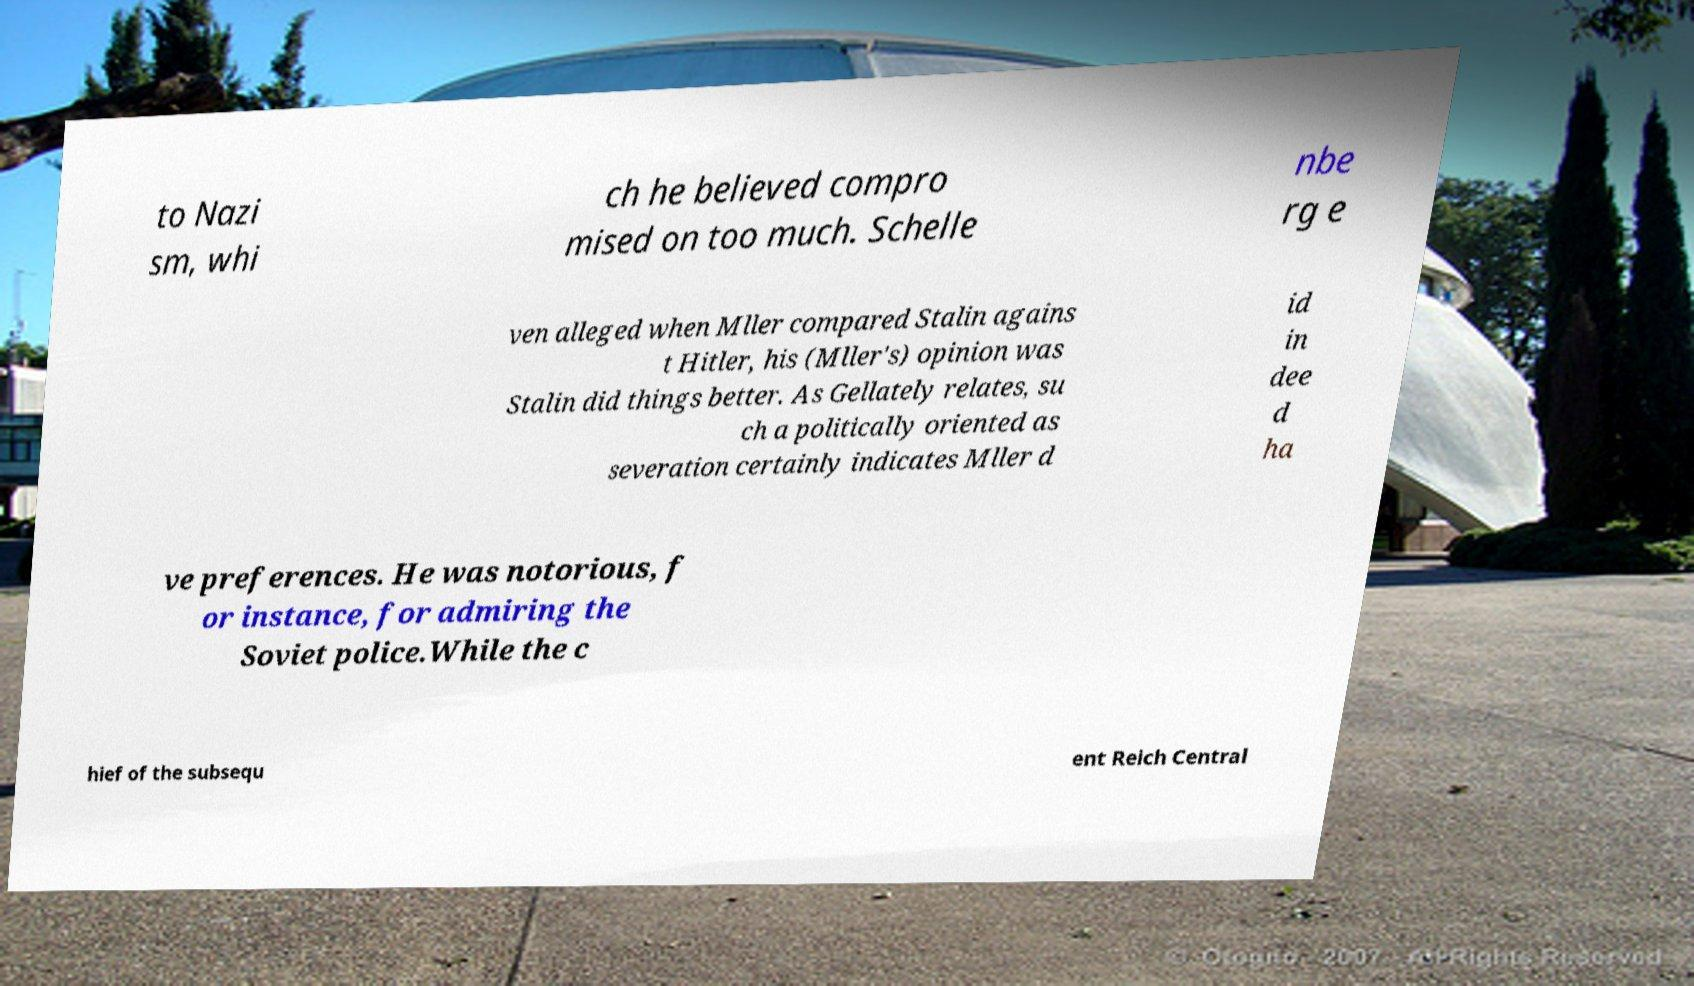Could you extract and type out the text from this image? to Nazi sm, whi ch he believed compro mised on too much. Schelle nbe rg e ven alleged when Mller compared Stalin agains t Hitler, his (Mller's) opinion was Stalin did things better. As Gellately relates, su ch a politically oriented as severation certainly indicates Mller d id in dee d ha ve preferences. He was notorious, f or instance, for admiring the Soviet police.While the c hief of the subsequ ent Reich Central 